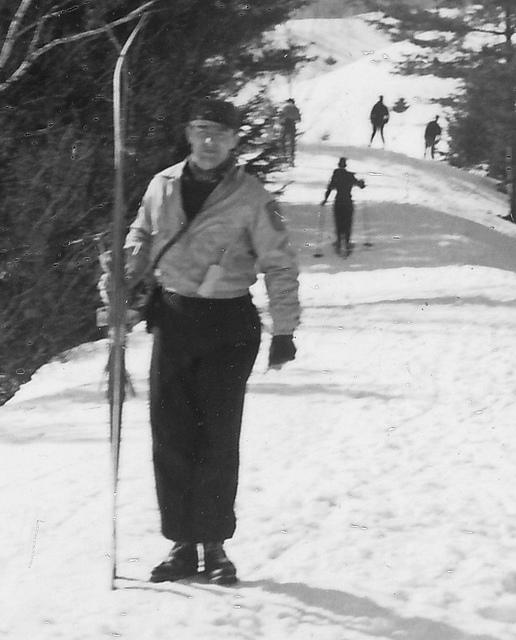What is he wearing on his head?
Be succinct. Hat. What does the person have in their right hand?
Quick response, please. Skis. Is the man enjoying himself?
Give a very brief answer. Yes. What does this lady have on her feet?
Quick response, please. Shoes. Is the person doing a performance?
Be succinct. No. Is it winter time?
Short answer required. Yes. Is it snowing?
Write a very short answer. No. Is this a recent photo?
Write a very short answer. No. Is he skating or walking?
Write a very short answer. Walking. Is the man wearing glasses?
Answer briefly. No. Is the man skiing?
Give a very brief answer. Yes. Is he taking long steps?
Be succinct. No. 